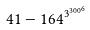Convert formula to latex. <formula><loc_0><loc_0><loc_500><loc_500>4 1 - 1 6 4 ^ { { 3 ^ { 3 0 0 } } ^ { 6 } }</formula> 